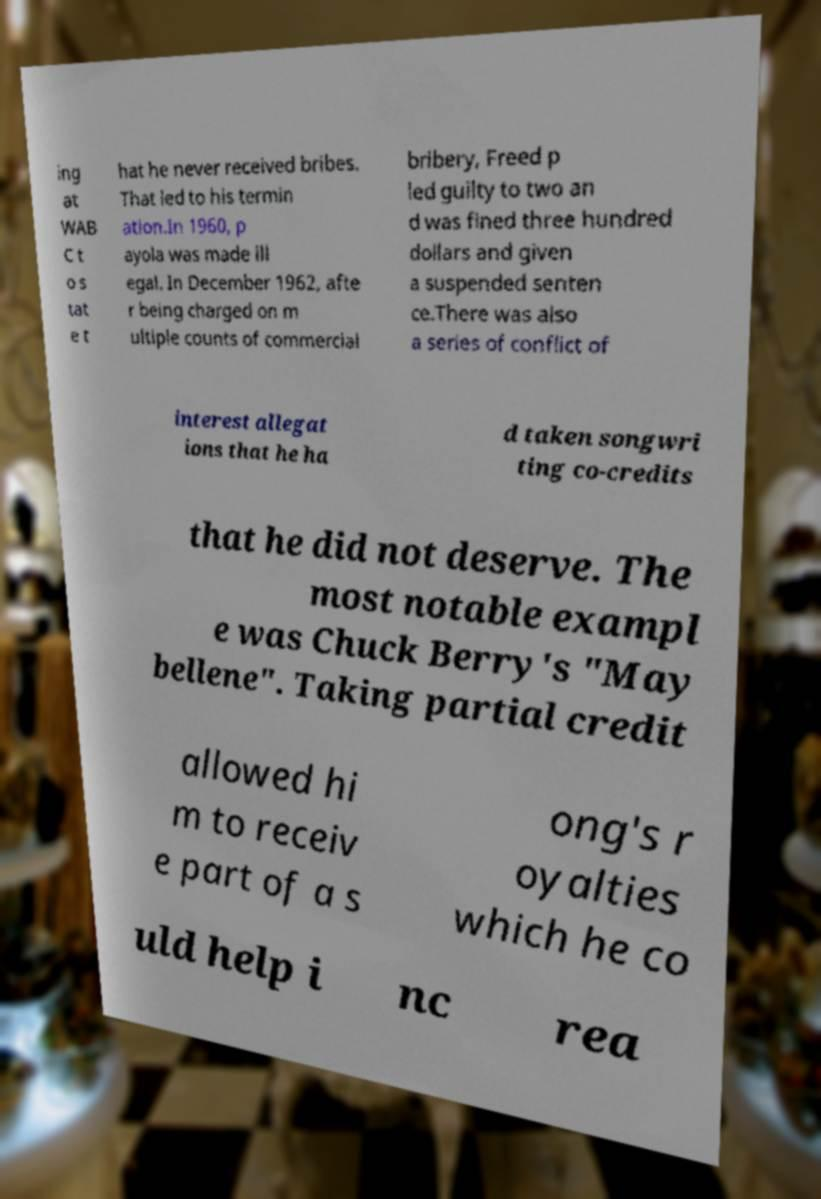Could you assist in decoding the text presented in this image and type it out clearly? ing at WAB C t o s tat e t hat he never received bribes. That led to his termin ation.In 1960, p ayola was made ill egal. In December 1962, afte r being charged on m ultiple counts of commercial bribery, Freed p led guilty to two an d was fined three hundred dollars and given a suspended senten ce.There was also a series of conflict of interest allegat ions that he ha d taken songwri ting co-credits that he did not deserve. The most notable exampl e was Chuck Berry's "May bellene". Taking partial credit allowed hi m to receiv e part of a s ong's r oyalties which he co uld help i nc rea 